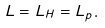Convert formula to latex. <formula><loc_0><loc_0><loc_500><loc_500>L = L _ { H } = L _ { p } .</formula> 